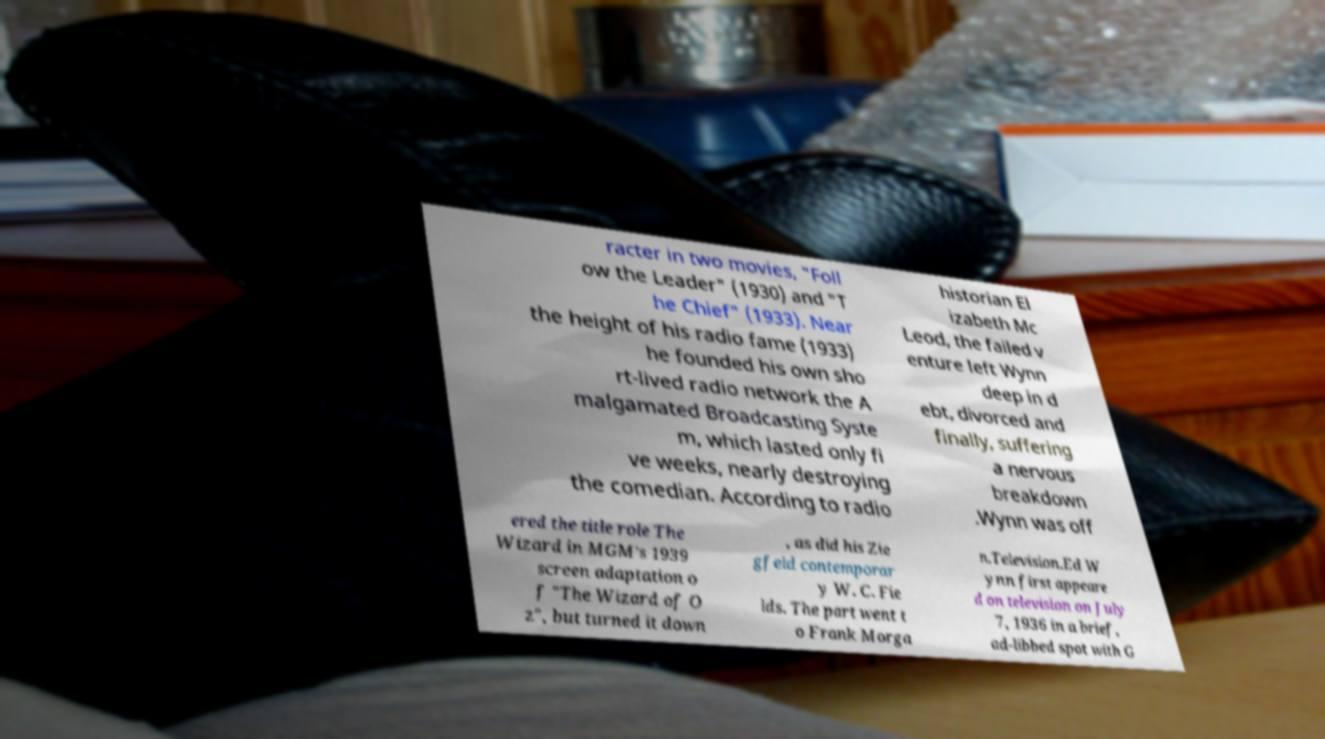Could you extract and type out the text from this image? racter in two movies, "Foll ow the Leader" (1930) and "T he Chief" (1933). Near the height of his radio fame (1933) he founded his own sho rt-lived radio network the A malgamated Broadcasting Syste m, which lasted only fi ve weeks, nearly destroying the comedian. According to radio historian El izabeth Mc Leod, the failed v enture left Wynn deep in d ebt, divorced and finally, suffering a nervous breakdown .Wynn was off ered the title role The Wizard in MGM's 1939 screen adaptation o f "The Wizard of O z", but turned it down , as did his Zie gfeld contemporar y W. C. Fie lds. The part went t o Frank Morga n.Television.Ed W ynn first appeare d on television on July 7, 1936 in a brief, ad-libbed spot with G 